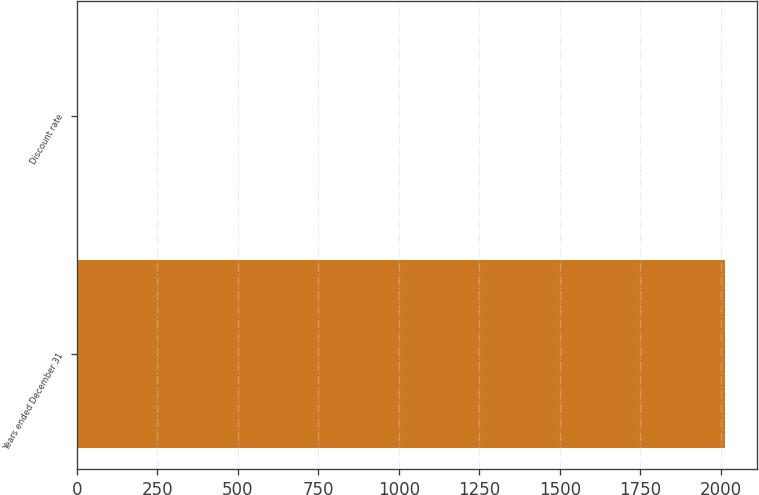Convert chart. <chart><loc_0><loc_0><loc_500><loc_500><bar_chart><fcel>Years ended December 31<fcel>Discount rate<nl><fcel>2012<fcel>5<nl></chart> 